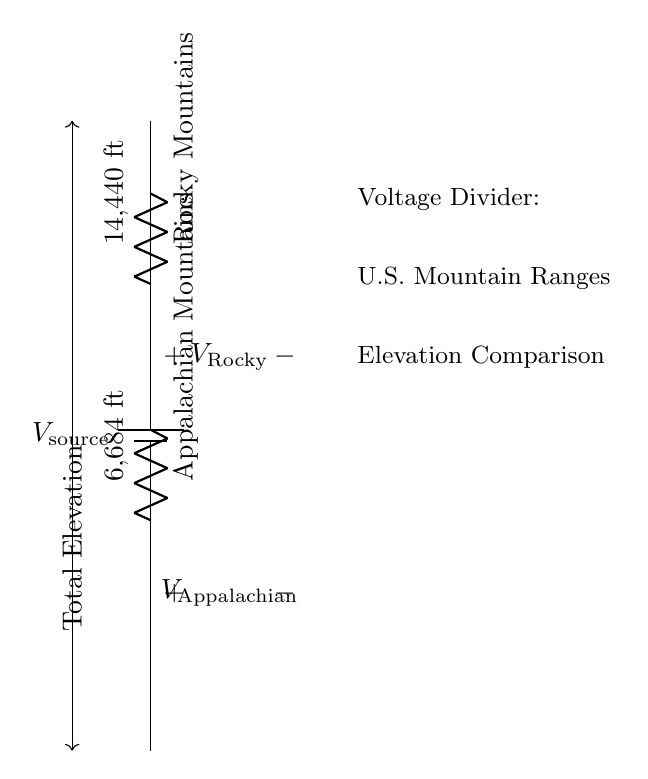What is the source voltage represented in the circuit? The source voltage is depicted as the voltage of the battery in the circuit diagram. It acts as the input for the voltage divider. However, the exact value of the source voltage isn't provided in the diagram, so it remains unspecified.
Answer: unspecified What is the highest elevation in the circuit? The highest elevation is labeled next to the Rocky Mountains in the circuit diagram, which is noted as 14,440 feet. This indicates the maximum height represented by the resistive element associated with that mountain range.
Answer: 14,440 ft What is the lower elevation shown in the circuit? The lower elevation is associated with the Appalachian Mountains in the circuit diagram and is indicated as 6,684 feet. This provides the comparison of the two mountain ranges.
Answer: 6,684 ft What does the voltage labeled \(V_\text{Rocky}\) represent? The voltage labeled \(V_\text{Rocky}\) in the circuit represents the voltage drop across the resistor representing the Rocky Mountains. This corresponds to its elevation relative to the source voltage.
Answer: voltage drop across Rocky Mountains How does the voltage drop across the Appalachian Mountains compare to that of the Rockies? The Appalachian Mountains have a significantly lower voltage drop compared to the Rocky Mountains due to the difference in their elevations; this voltage drop reflects the elevation difference effectively.
Answer: lower voltage drop What does the open voltage indicators in the circuit suggest? The open voltage indicators \(V_\text{Rocky}\) and \(V_\text{Appalachian}\) signify that these are points where the voltage measurements can be taken within the circuit, specifically across each mountain range’s resistor.
Answer: voltage measurement points What do the arrows in the diagram represent? The arrows between the resistors denote the direction in which the voltage is considered to drop through each resistor and indicate that the total elevation is being evaluated in a top-down manner from the source voltage.
Answer: direction of voltage drop 